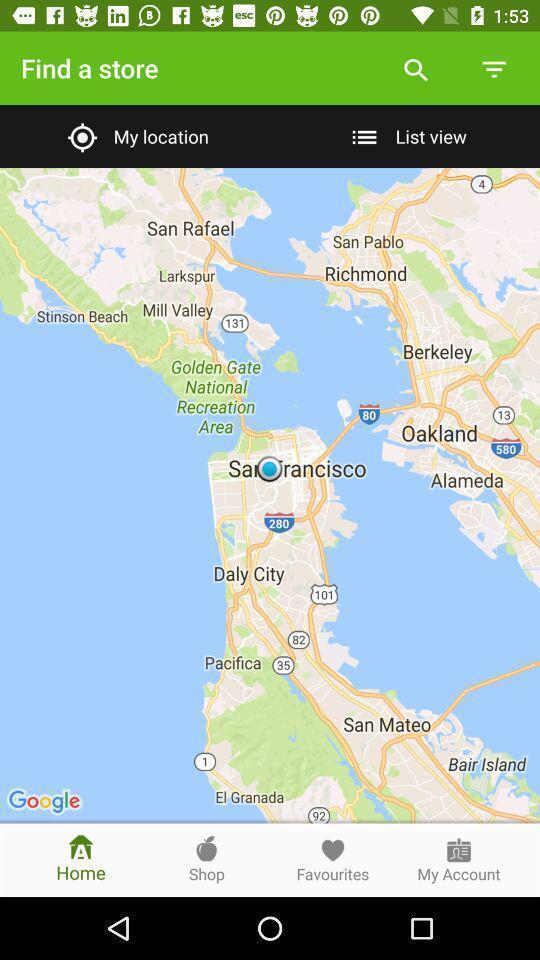Tell me what you see in this picture. Search page displaying map view of location. 